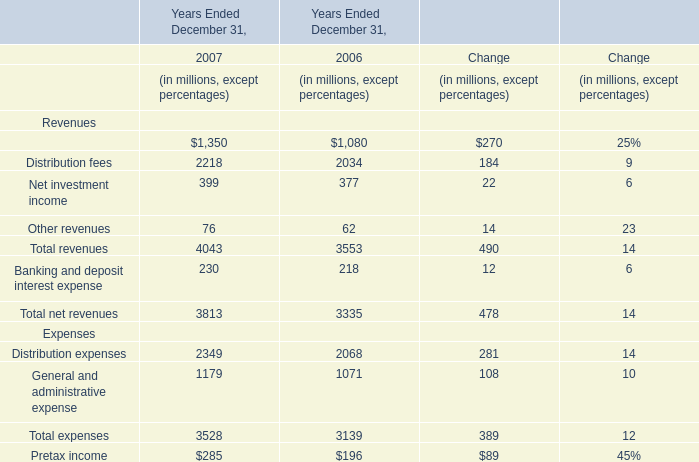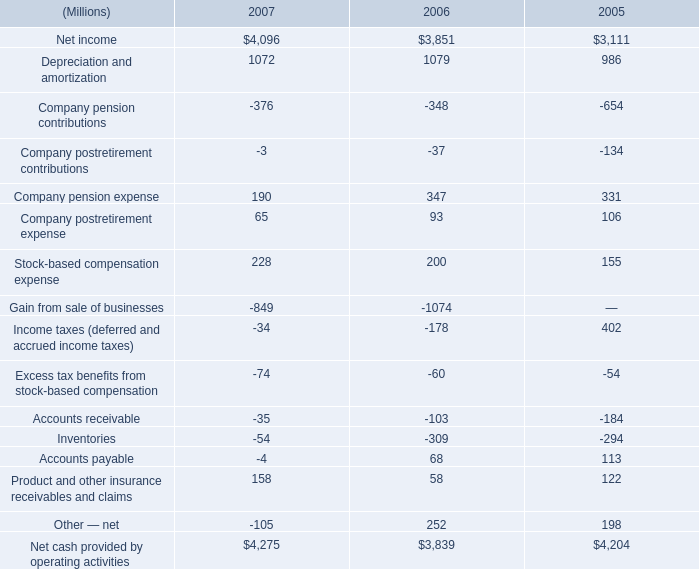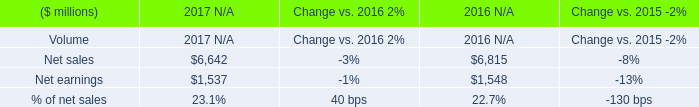What is the total amount of Net cash provided by operating activities of 2006, Net earnings of 2017 N/A, and Net cash provided by operating activities of 2007 ? 
Computations: ((3839.0 + 1537.0) + 4275.0)
Answer: 9651.0. 